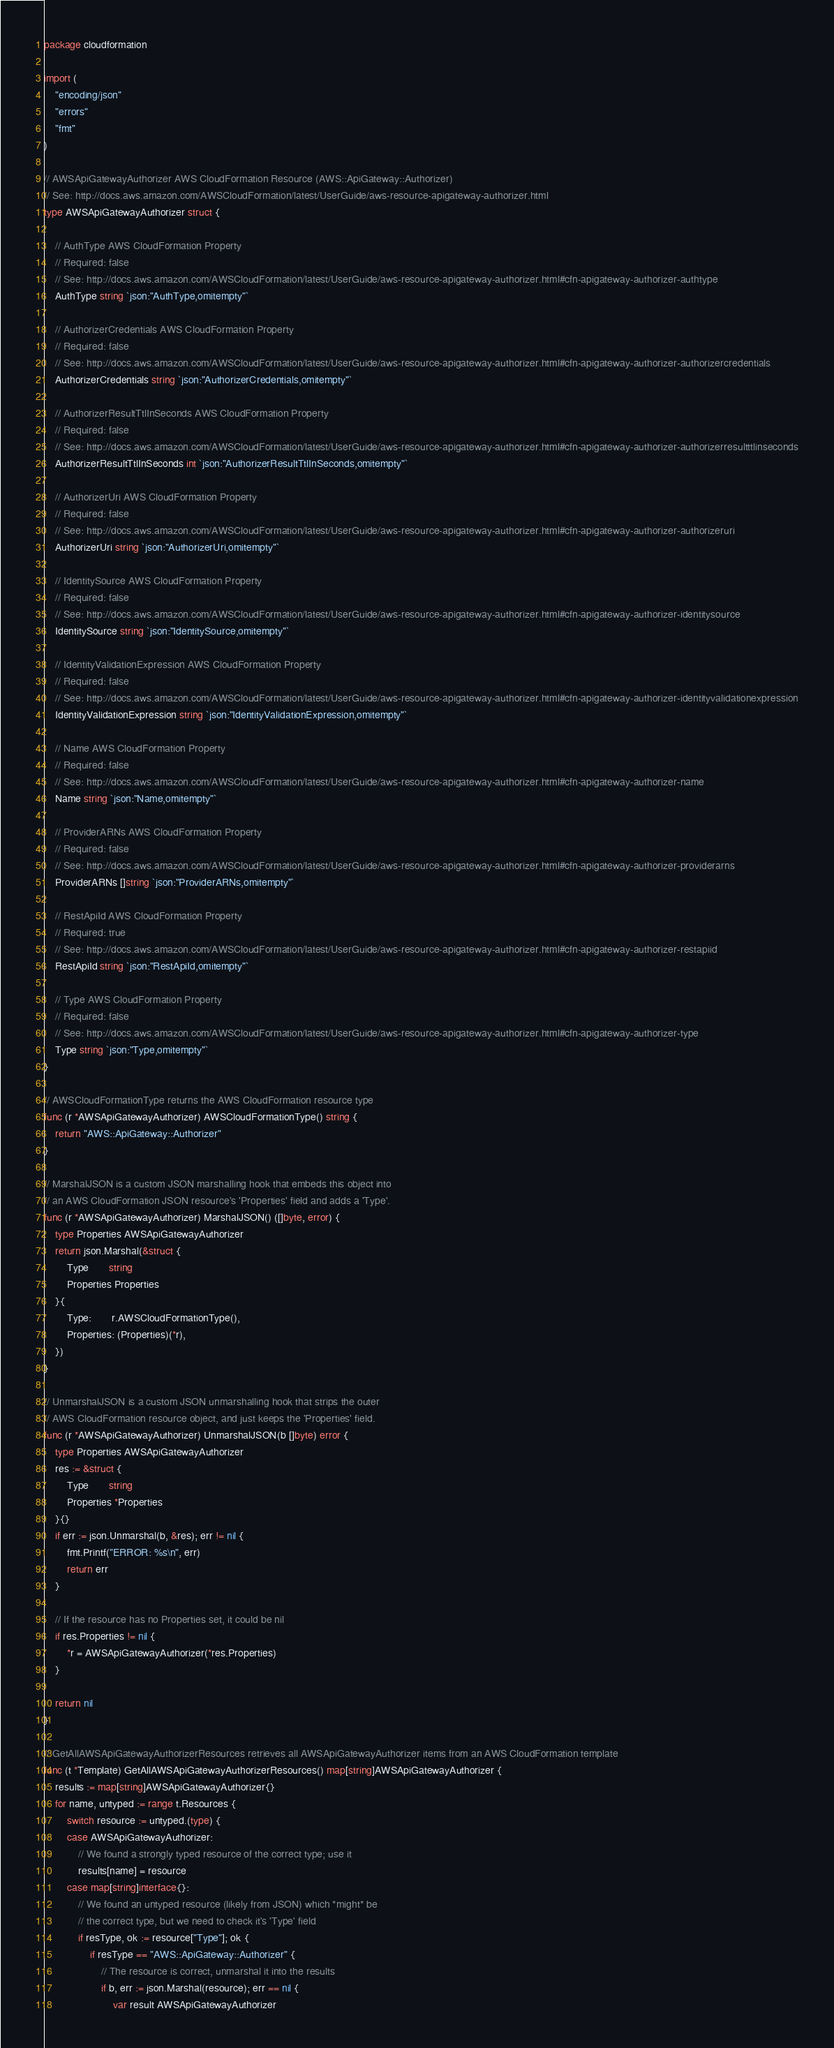Convert code to text. <code><loc_0><loc_0><loc_500><loc_500><_Go_>package cloudformation

import (
	"encoding/json"
	"errors"
	"fmt"
)

// AWSApiGatewayAuthorizer AWS CloudFormation Resource (AWS::ApiGateway::Authorizer)
// See: http://docs.aws.amazon.com/AWSCloudFormation/latest/UserGuide/aws-resource-apigateway-authorizer.html
type AWSApiGatewayAuthorizer struct {

	// AuthType AWS CloudFormation Property
	// Required: false
	// See: http://docs.aws.amazon.com/AWSCloudFormation/latest/UserGuide/aws-resource-apigateway-authorizer.html#cfn-apigateway-authorizer-authtype
	AuthType string `json:"AuthType,omitempty"`

	// AuthorizerCredentials AWS CloudFormation Property
	// Required: false
	// See: http://docs.aws.amazon.com/AWSCloudFormation/latest/UserGuide/aws-resource-apigateway-authorizer.html#cfn-apigateway-authorizer-authorizercredentials
	AuthorizerCredentials string `json:"AuthorizerCredentials,omitempty"`

	// AuthorizerResultTtlInSeconds AWS CloudFormation Property
	// Required: false
	// See: http://docs.aws.amazon.com/AWSCloudFormation/latest/UserGuide/aws-resource-apigateway-authorizer.html#cfn-apigateway-authorizer-authorizerresultttlinseconds
	AuthorizerResultTtlInSeconds int `json:"AuthorizerResultTtlInSeconds,omitempty"`

	// AuthorizerUri AWS CloudFormation Property
	// Required: false
	// See: http://docs.aws.amazon.com/AWSCloudFormation/latest/UserGuide/aws-resource-apigateway-authorizer.html#cfn-apigateway-authorizer-authorizeruri
	AuthorizerUri string `json:"AuthorizerUri,omitempty"`

	// IdentitySource AWS CloudFormation Property
	// Required: false
	// See: http://docs.aws.amazon.com/AWSCloudFormation/latest/UserGuide/aws-resource-apigateway-authorizer.html#cfn-apigateway-authorizer-identitysource
	IdentitySource string `json:"IdentitySource,omitempty"`

	// IdentityValidationExpression AWS CloudFormation Property
	// Required: false
	// See: http://docs.aws.amazon.com/AWSCloudFormation/latest/UserGuide/aws-resource-apigateway-authorizer.html#cfn-apigateway-authorizer-identityvalidationexpression
	IdentityValidationExpression string `json:"IdentityValidationExpression,omitempty"`

	// Name AWS CloudFormation Property
	// Required: false
	// See: http://docs.aws.amazon.com/AWSCloudFormation/latest/UserGuide/aws-resource-apigateway-authorizer.html#cfn-apigateway-authorizer-name
	Name string `json:"Name,omitempty"`

	// ProviderARNs AWS CloudFormation Property
	// Required: false
	// See: http://docs.aws.amazon.com/AWSCloudFormation/latest/UserGuide/aws-resource-apigateway-authorizer.html#cfn-apigateway-authorizer-providerarns
	ProviderARNs []string `json:"ProviderARNs,omitempty"`

	// RestApiId AWS CloudFormation Property
	// Required: true
	// See: http://docs.aws.amazon.com/AWSCloudFormation/latest/UserGuide/aws-resource-apigateway-authorizer.html#cfn-apigateway-authorizer-restapiid
	RestApiId string `json:"RestApiId,omitempty"`

	// Type AWS CloudFormation Property
	// Required: false
	// See: http://docs.aws.amazon.com/AWSCloudFormation/latest/UserGuide/aws-resource-apigateway-authorizer.html#cfn-apigateway-authorizer-type
	Type string `json:"Type,omitempty"`
}

// AWSCloudFormationType returns the AWS CloudFormation resource type
func (r *AWSApiGatewayAuthorizer) AWSCloudFormationType() string {
	return "AWS::ApiGateway::Authorizer"
}

// MarshalJSON is a custom JSON marshalling hook that embeds this object into
// an AWS CloudFormation JSON resource's 'Properties' field and adds a 'Type'.
func (r *AWSApiGatewayAuthorizer) MarshalJSON() ([]byte, error) {
	type Properties AWSApiGatewayAuthorizer
	return json.Marshal(&struct {
		Type       string
		Properties Properties
	}{
		Type:       r.AWSCloudFormationType(),
		Properties: (Properties)(*r),
	})
}

// UnmarshalJSON is a custom JSON unmarshalling hook that strips the outer
// AWS CloudFormation resource object, and just keeps the 'Properties' field.
func (r *AWSApiGatewayAuthorizer) UnmarshalJSON(b []byte) error {
	type Properties AWSApiGatewayAuthorizer
	res := &struct {
		Type       string
		Properties *Properties
	}{}
	if err := json.Unmarshal(b, &res); err != nil {
		fmt.Printf("ERROR: %s\n", err)
		return err
	}

	// If the resource has no Properties set, it could be nil
	if res.Properties != nil {
		*r = AWSApiGatewayAuthorizer(*res.Properties)
	}

	return nil
}

// GetAllAWSApiGatewayAuthorizerResources retrieves all AWSApiGatewayAuthorizer items from an AWS CloudFormation template
func (t *Template) GetAllAWSApiGatewayAuthorizerResources() map[string]AWSApiGatewayAuthorizer {
	results := map[string]AWSApiGatewayAuthorizer{}
	for name, untyped := range t.Resources {
		switch resource := untyped.(type) {
		case AWSApiGatewayAuthorizer:
			// We found a strongly typed resource of the correct type; use it
			results[name] = resource
		case map[string]interface{}:
			// We found an untyped resource (likely from JSON) which *might* be
			// the correct type, but we need to check it's 'Type' field
			if resType, ok := resource["Type"]; ok {
				if resType == "AWS::ApiGateway::Authorizer" {
					// The resource is correct, unmarshal it into the results
					if b, err := json.Marshal(resource); err == nil {
						var result AWSApiGatewayAuthorizer</code> 